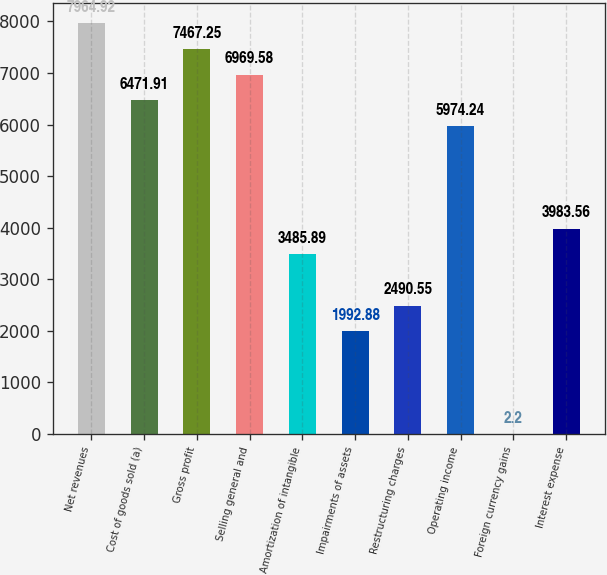Convert chart. <chart><loc_0><loc_0><loc_500><loc_500><bar_chart><fcel>Net revenues<fcel>Cost of goods sold (a)<fcel>Gross profit<fcel>Selling general and<fcel>Amortization of intangible<fcel>Impairments of assets<fcel>Restructuring charges<fcel>Operating income<fcel>Foreign currency gains<fcel>Interest expense<nl><fcel>7964.92<fcel>6471.91<fcel>7467.25<fcel>6969.58<fcel>3485.89<fcel>1992.88<fcel>2490.55<fcel>5974.24<fcel>2.2<fcel>3983.56<nl></chart> 